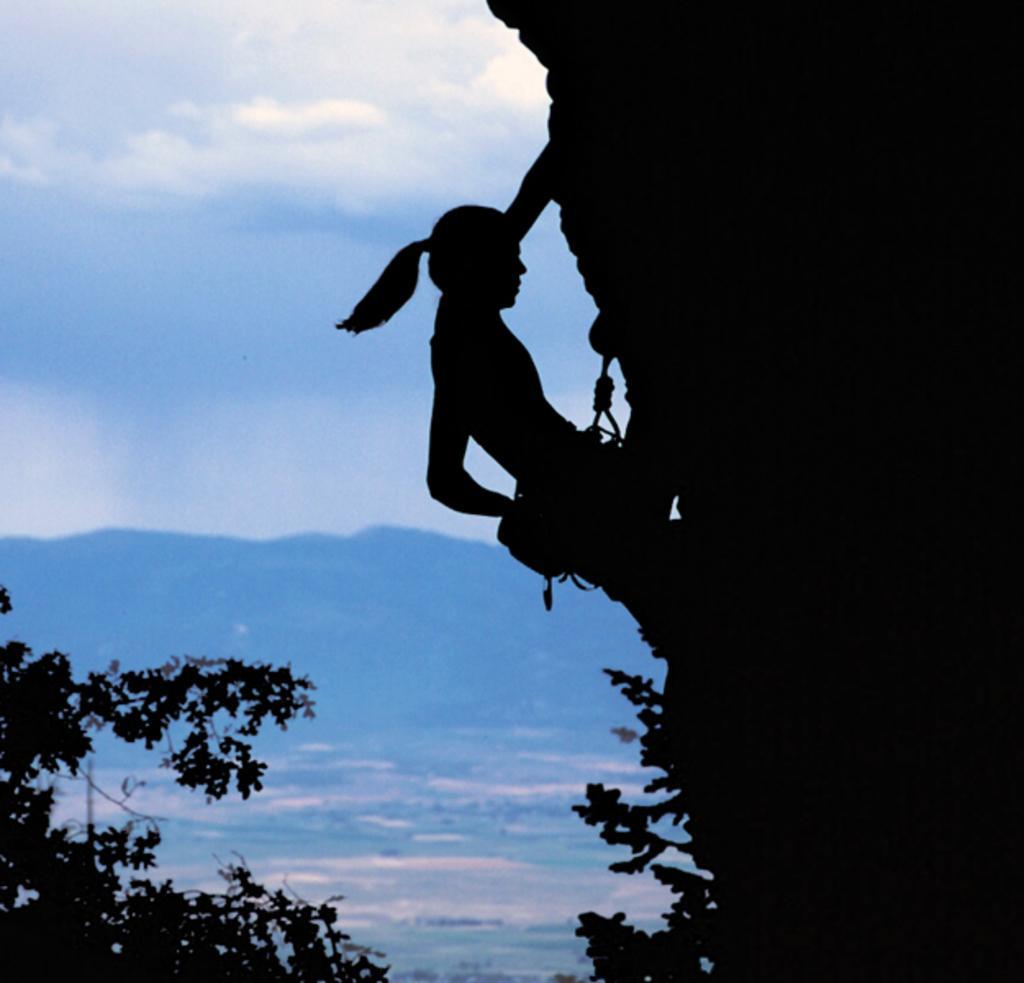How would you summarize this image in a sentence or two? In this picture there is a woman climbing the hill towards the right. At the bottom there are trees. In the background there is a hill and a sky. 